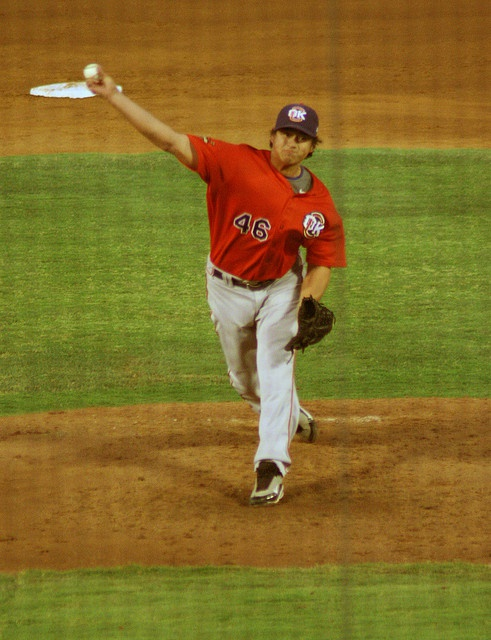Describe the objects in this image and their specific colors. I can see people in maroon, brown, darkgray, and tan tones, baseball glove in maroon, black, olive, and tan tones, and sports ball in maroon, beige, and tan tones in this image. 